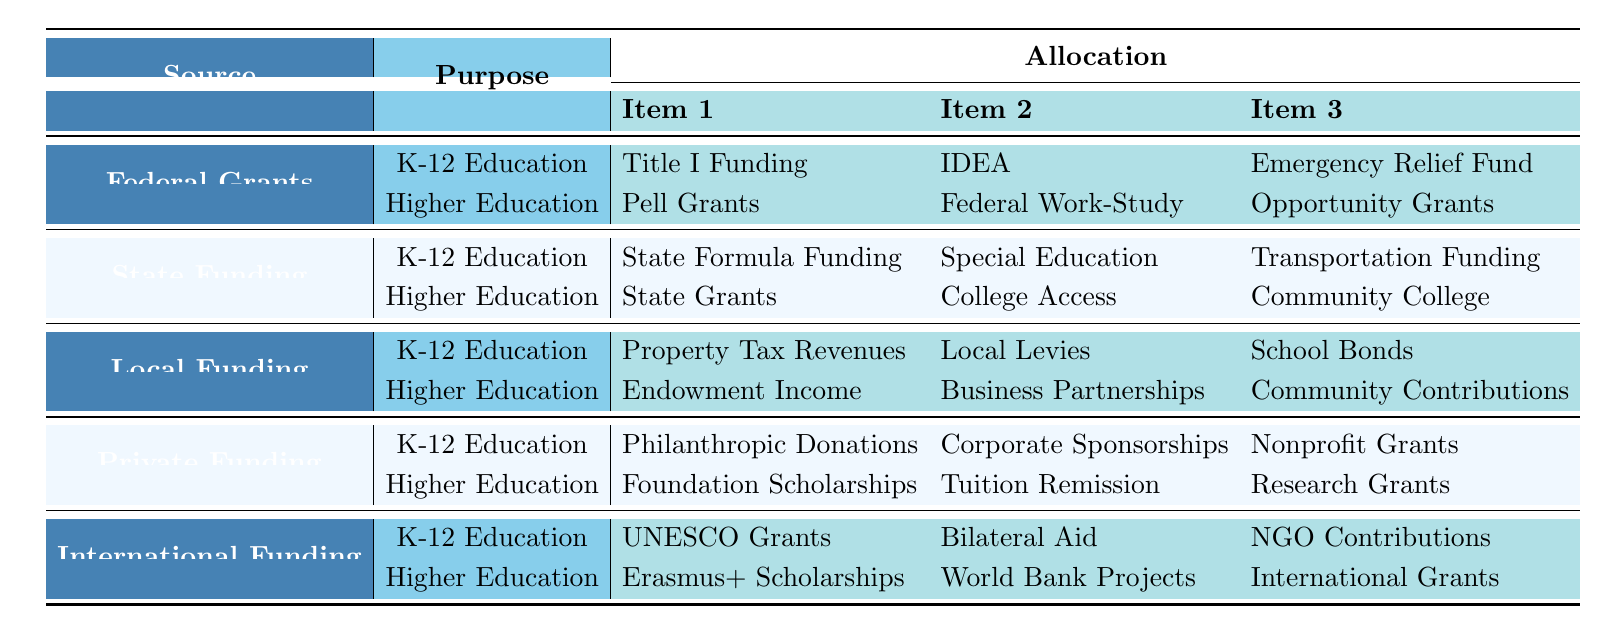What are three sources of educational funding mentioned in the table? The table lists five sources: Federal Grants, State Funding, Local Funding, Private Funding, and International Funding. The question requires identifying any three of these sources, which can be seen directly in the table under the "Source" column.
Answer: Federal Grants, State Funding, Local Funding How many different purposes are there for K-12 education funding? The table shows two main purposes for K-12 education funding: one from Federal Grants and another from State Funding, Local Funding, Private Funding, and International Funding. Each of these sources has a dedicated section for K-12 education, reflecting the purposes listed. Therefore, there are a total of five different purposes.
Answer: Five Which item is the first under Higher Education in International Funding? In the table, the first item listed under Higher Education for International Funding is "Erasmus+ Scholarships." This can be found by locating the row for International Funding and looking specifically at the designation for Higher Education.
Answer: Erasmus+ Scholarships Is "Pell Grants" listed under K-12 education funding? "Pell Grants" is indicated under the purpose for Higher Education funding and not under K-12 education in the table. This suggests that the funding is specifically designated for higher education students. Therefore, the answer is no.
Answer: No Which source has the least number of items listed for Higher Education? By counting the items under Higher Education for each source: Federal Grants (3), State Funding (3), Local Funding (3), Private Funding (3), and International Funding (3), all sources have the same number of items listed (3). Consequently, there is no single source with fewer items; they are all equal.
Answer: All have the same number What is the relationship between State Funding and Special Education? The table shows that Special Education Funding is listed under the category of K-12 Education purposes and is specifically funded by State Funding. This indicates that there is a direct allocation for Special Education under the umbrella of State Funding for K-12 education.
Answer: Special Education is funded by State Funding How many total items are listed for K-12 education funding? The total can be calculated by counting all items under K-12 education from each source. Federal Grants (3), State Funding (3), Local Funding (3), Private Funding (3), and International Funding (3), which gives a total of 5 sources x 3 items each = 15 items.
Answer: 15 In which funding source is "Community Contributions" found? The table designates "Community Contributions" under Local Funding for Higher Education. This can be directly found by looking for the item under the corresponding section for Higher Education.
Answer: Local Funding What are the total number of different funding items across all categories? To find the total number of items, count the items listed for K-12 (15 items) and add the items for Higher Education (15 items), leading to a total of 30 items when added together, representing the complete educational funding structure in the table.
Answer: 30 